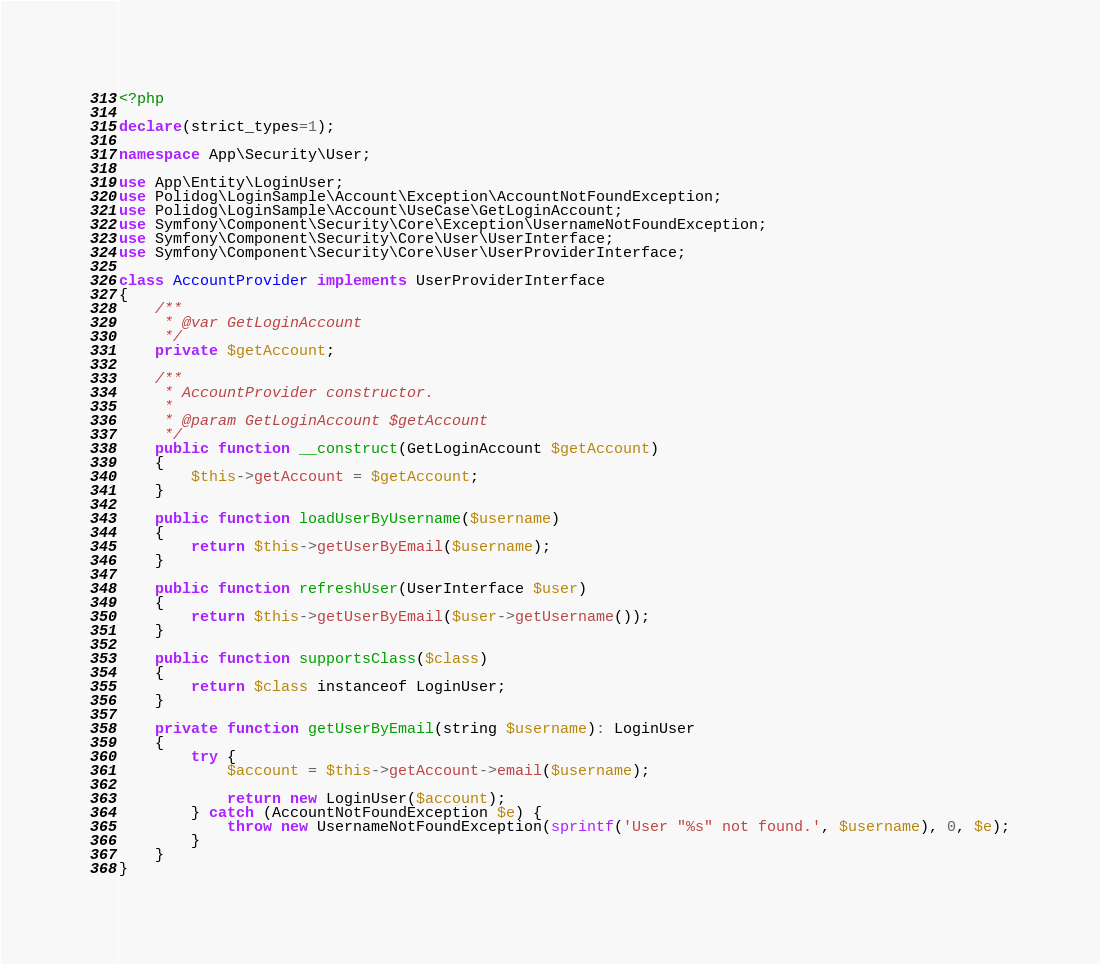<code> <loc_0><loc_0><loc_500><loc_500><_PHP_><?php

declare(strict_types=1);

namespace App\Security\User;

use App\Entity\LoginUser;
use Polidog\LoginSample\Account\Exception\AccountNotFoundException;
use Polidog\LoginSample\Account\UseCase\GetLoginAccount;
use Symfony\Component\Security\Core\Exception\UsernameNotFoundException;
use Symfony\Component\Security\Core\User\UserInterface;
use Symfony\Component\Security\Core\User\UserProviderInterface;

class AccountProvider implements UserProviderInterface
{
    /**
     * @var GetLoginAccount
     */
    private $getAccount;

    /**
     * AccountProvider constructor.
     *
     * @param GetLoginAccount $getAccount
     */
    public function __construct(GetLoginAccount $getAccount)
    {
        $this->getAccount = $getAccount;
    }

    public function loadUserByUsername($username)
    {
        return $this->getUserByEmail($username);
    }

    public function refreshUser(UserInterface $user)
    {
        return $this->getUserByEmail($user->getUsername());
    }

    public function supportsClass($class)
    {
        return $class instanceof LoginUser;
    }

    private function getUserByEmail(string $username): LoginUser
    {
        try {
            $account = $this->getAccount->email($username);

            return new LoginUser($account);
        } catch (AccountNotFoundException $e) {
            throw new UsernameNotFoundException(sprintf('User "%s" not found.', $username), 0, $e);
        }
    }
}
</code> 